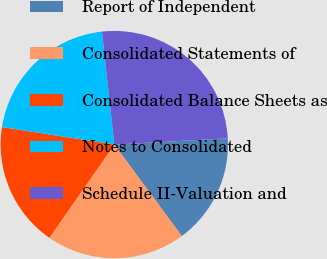<chart> <loc_0><loc_0><loc_500><loc_500><pie_chart><fcel>Report of Independent<fcel>Consolidated Statements of<fcel>Consolidated Balance Sheets as<fcel>Notes to Consolidated<fcel>Schedule II-Valuation and<nl><fcel>15.76%<fcel>19.8%<fcel>17.78%<fcel>20.81%<fcel>25.86%<nl></chart> 